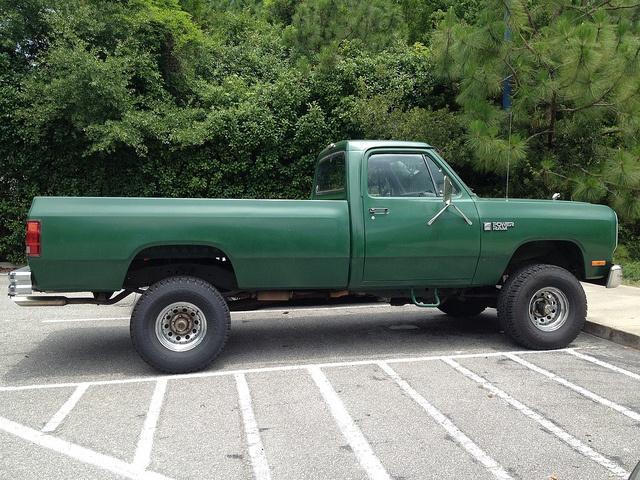Describe the objects in this image and their specific colors. I can see a truck in darkgreen, black, teal, and gray tones in this image. 